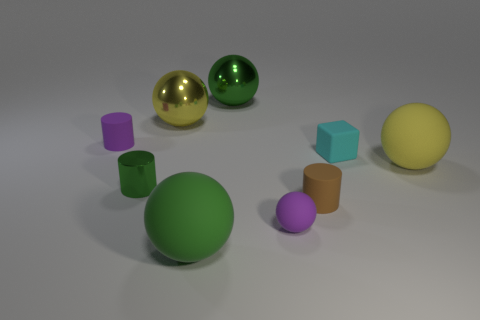Subtract all purple spheres. How many spheres are left? 4 Subtract all green metallic balls. How many balls are left? 4 Subtract all brown spheres. Subtract all cyan cylinders. How many spheres are left? 5 Add 1 big green rubber objects. How many objects exist? 10 Subtract all balls. How many objects are left? 4 Subtract all green rubber things. Subtract all brown cylinders. How many objects are left? 7 Add 6 small blocks. How many small blocks are left? 7 Add 5 brown cylinders. How many brown cylinders exist? 6 Subtract 0 cyan cylinders. How many objects are left? 9 